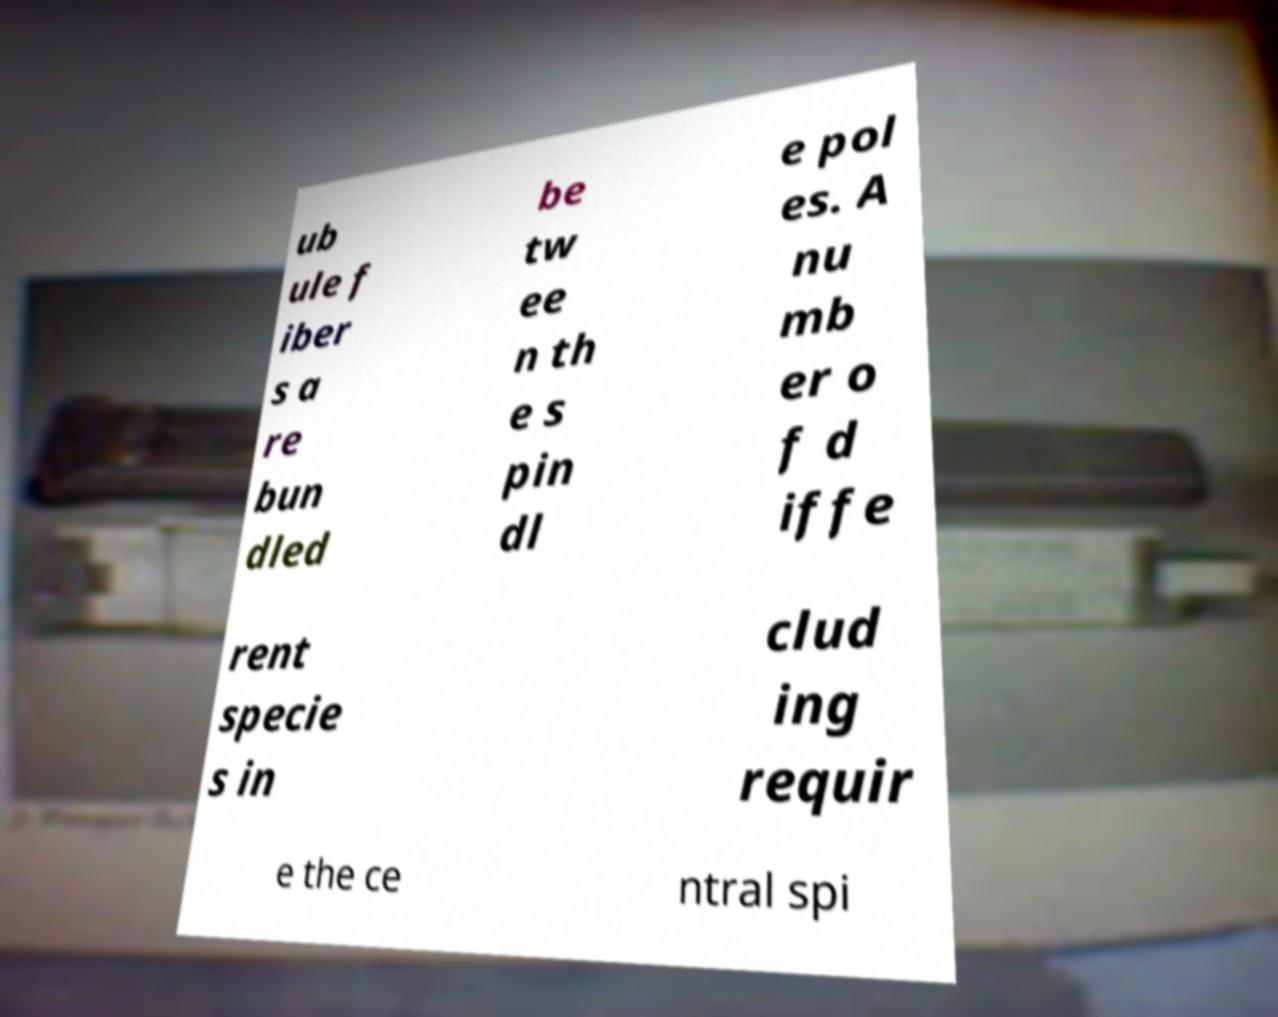For documentation purposes, I need the text within this image transcribed. Could you provide that? ub ule f iber s a re bun dled be tw ee n th e s pin dl e pol es. A nu mb er o f d iffe rent specie s in clud ing requir e the ce ntral spi 